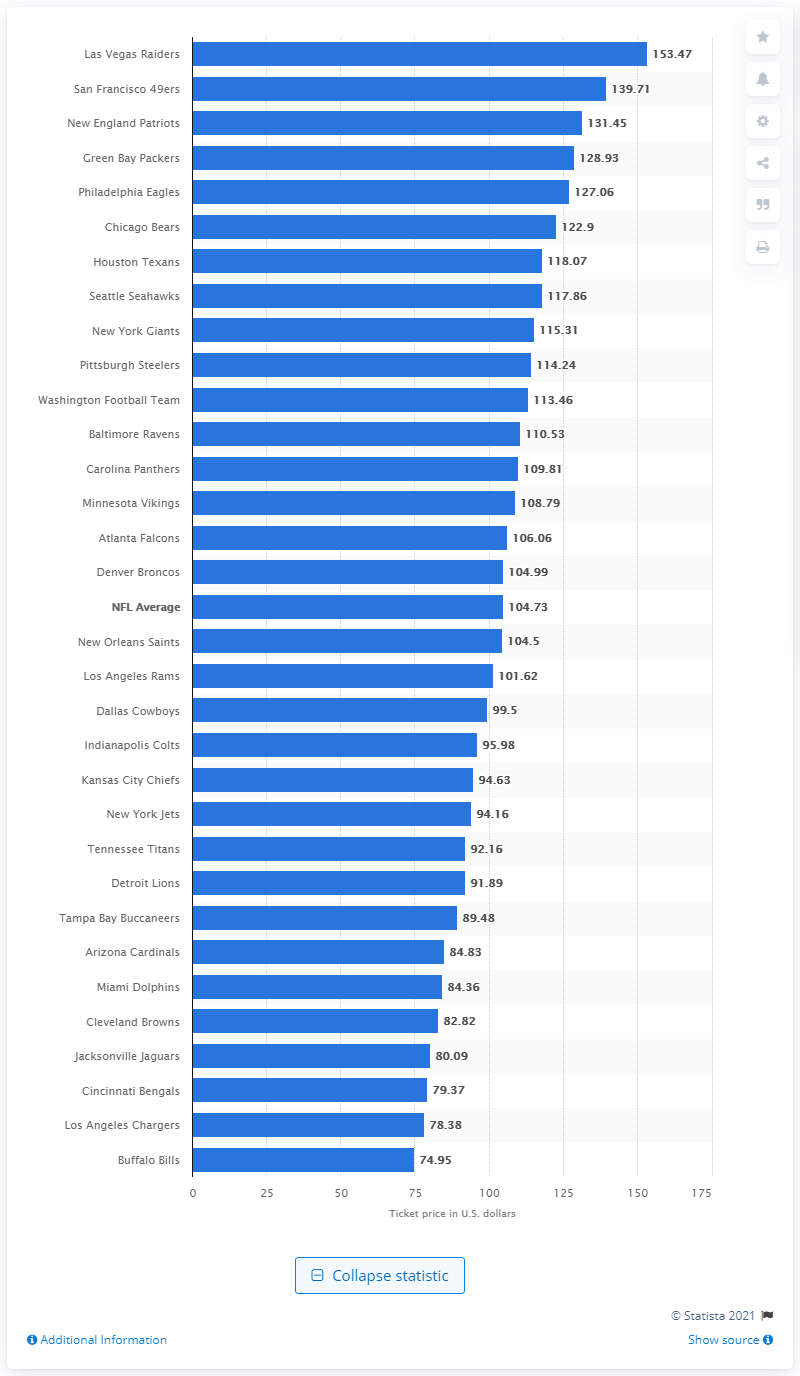Draw attention to some important aspects in this diagram. The average cost of a home game for the Buffalo Bills was $74.95. 